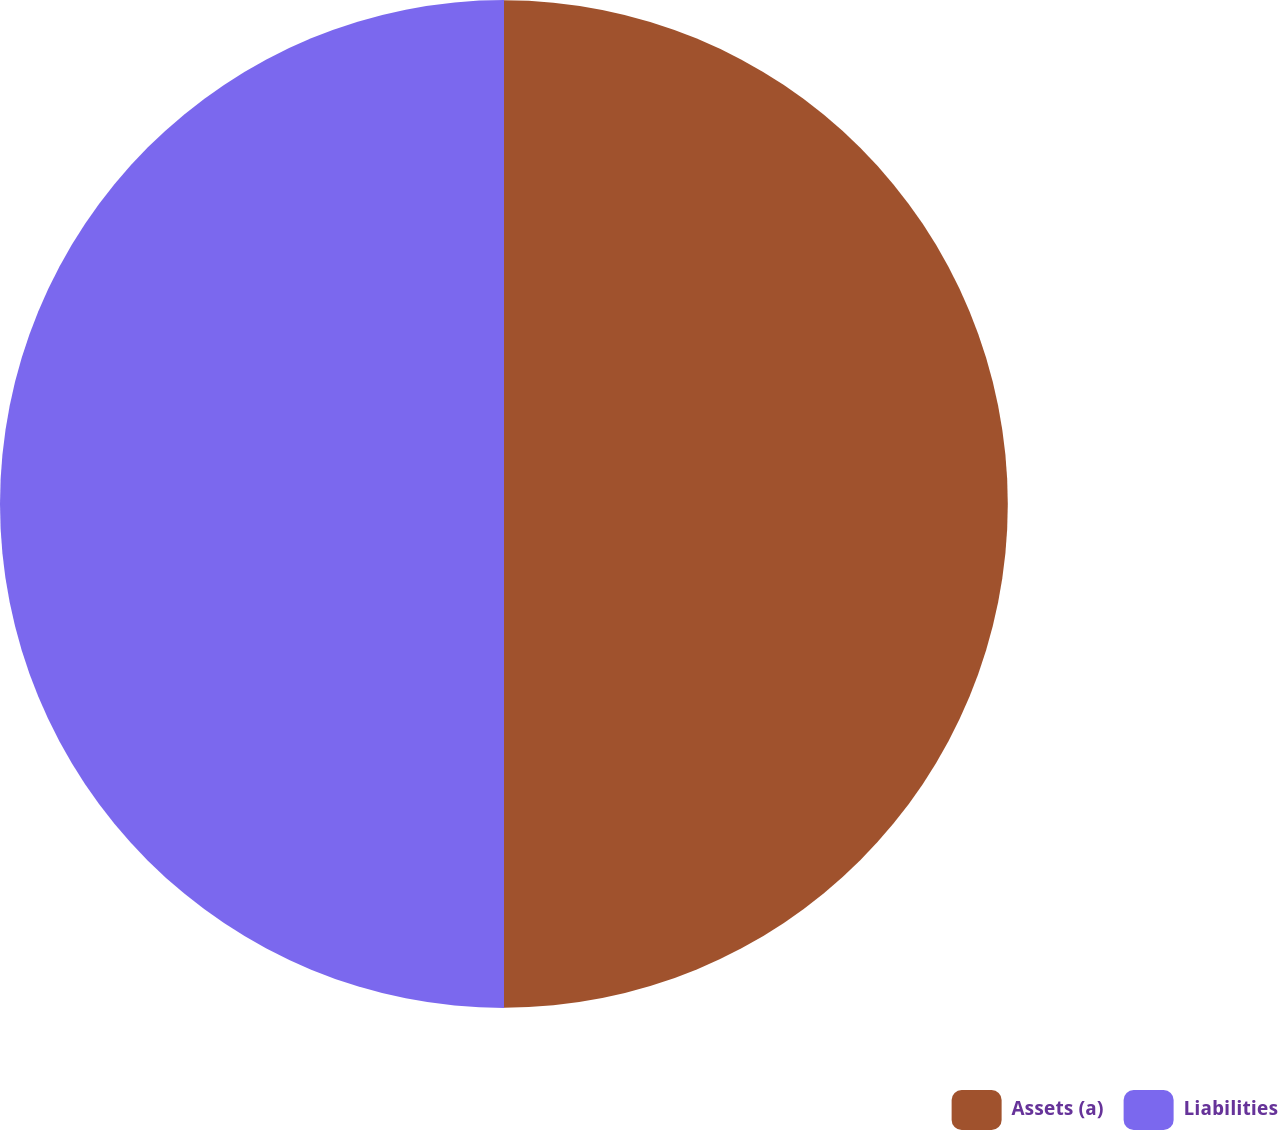<chart> <loc_0><loc_0><loc_500><loc_500><pie_chart><fcel>Assets (a)<fcel>Liabilities<nl><fcel>49.99%<fcel>50.01%<nl></chart> 